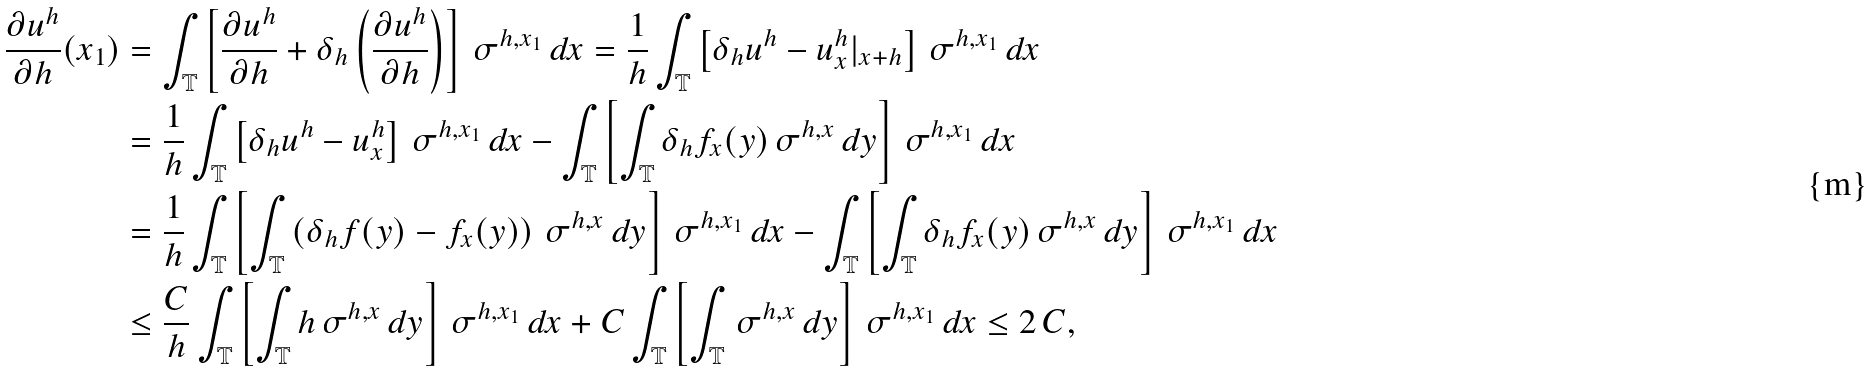Convert formula to latex. <formula><loc_0><loc_0><loc_500><loc_500>\frac { \partial u ^ { h } } { \partial h } ( x _ { 1 } ) & = \int _ { \mathbb { T } } \left [ \frac { \partial u ^ { h } } { \partial h } + \delta _ { h } \left ( \frac { \partial u ^ { h } } { \partial h } \right ) \right ] \, \sigma ^ { h , x _ { 1 } } \, d x = \frac { 1 } { h } \int _ { \mathbb { T } } \left [ \delta _ { h } u ^ { h } - u ^ { h } _ { x } | _ { x + h } \right ] \, \sigma ^ { h , x _ { 1 } } \, d x \\ & = \frac { 1 } { h } \int _ { \mathbb { T } } \left [ \delta _ { h } u ^ { h } - u ^ { h } _ { x } \right ] \, \sigma ^ { h , x _ { 1 } } \, d x - \int _ { \mathbb { T } } \left [ \int _ { \mathbb { T } } \delta _ { h } f _ { x } ( y ) \, \sigma ^ { h , x } \, d y \right ] \, \sigma ^ { h , x _ { 1 } } \, d x \\ & = \frac { 1 } { h } \int _ { \mathbb { T } } \left [ \int _ { \mathbb { T } } \left ( \delta _ { h } f ( y ) - f _ { x } ( y ) \right ) \, \sigma ^ { h , x } \, d y \right ] \, \sigma ^ { h , x _ { 1 } } \, d x - \int _ { \mathbb { T } } \left [ \int _ { \mathbb { T } } \delta _ { h } f _ { x } ( y ) \, \sigma ^ { h , x } \, d y \right ] \, \sigma ^ { h , x _ { 1 } } \, d x \\ & \leq \frac { C } { h } \int _ { \mathbb { T } } \left [ \int _ { \mathbb { T } } h \, \sigma ^ { h , x } \, d y \right ] \, \sigma ^ { h , x _ { 1 } } \, d x + C \int _ { \mathbb { T } } \left [ \int _ { \mathbb { T } } \, \sigma ^ { h , x } \, d y \right ] \, \sigma ^ { h , x _ { 1 } } \, d x \leq 2 \, C ,</formula> 